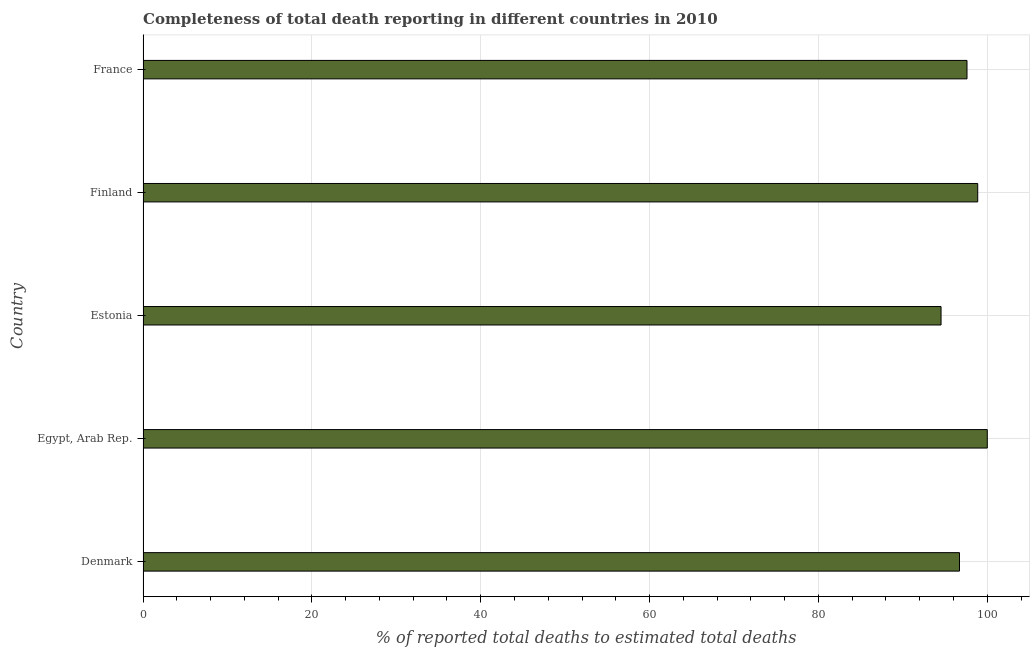Does the graph contain any zero values?
Offer a very short reply. No. Does the graph contain grids?
Give a very brief answer. Yes. What is the title of the graph?
Offer a very short reply. Completeness of total death reporting in different countries in 2010. What is the label or title of the X-axis?
Give a very brief answer. % of reported total deaths to estimated total deaths. What is the label or title of the Y-axis?
Your answer should be compact. Country. What is the completeness of total death reports in France?
Offer a very short reply. 97.6. Across all countries, what is the minimum completeness of total death reports?
Keep it short and to the point. 94.52. In which country was the completeness of total death reports maximum?
Provide a short and direct response. Egypt, Arab Rep. In which country was the completeness of total death reports minimum?
Give a very brief answer. Estonia. What is the sum of the completeness of total death reports?
Your answer should be very brief. 487.7. What is the difference between the completeness of total death reports in Egypt, Arab Rep. and Finland?
Offer a terse response. 1.13. What is the average completeness of total death reports per country?
Your answer should be compact. 97.54. What is the median completeness of total death reports?
Make the answer very short. 97.6. What is the difference between the highest and the second highest completeness of total death reports?
Give a very brief answer. 1.13. What is the difference between the highest and the lowest completeness of total death reports?
Keep it short and to the point. 5.48. In how many countries, is the completeness of total death reports greater than the average completeness of total death reports taken over all countries?
Provide a short and direct response. 3. How many bars are there?
Keep it short and to the point. 5. What is the difference between two consecutive major ticks on the X-axis?
Provide a short and direct response. 20. Are the values on the major ticks of X-axis written in scientific E-notation?
Provide a succinct answer. No. What is the % of reported total deaths to estimated total deaths in Denmark?
Your response must be concise. 96.71. What is the % of reported total deaths to estimated total deaths of Estonia?
Your answer should be compact. 94.52. What is the % of reported total deaths to estimated total deaths of Finland?
Offer a very short reply. 98.87. What is the % of reported total deaths to estimated total deaths of France?
Offer a very short reply. 97.6. What is the difference between the % of reported total deaths to estimated total deaths in Denmark and Egypt, Arab Rep.?
Ensure brevity in your answer.  -3.29. What is the difference between the % of reported total deaths to estimated total deaths in Denmark and Estonia?
Your answer should be compact. 2.19. What is the difference between the % of reported total deaths to estimated total deaths in Denmark and Finland?
Offer a very short reply. -2.16. What is the difference between the % of reported total deaths to estimated total deaths in Denmark and France?
Keep it short and to the point. -0.89. What is the difference between the % of reported total deaths to estimated total deaths in Egypt, Arab Rep. and Estonia?
Make the answer very short. 5.48. What is the difference between the % of reported total deaths to estimated total deaths in Egypt, Arab Rep. and Finland?
Provide a short and direct response. 1.13. What is the difference between the % of reported total deaths to estimated total deaths in Egypt, Arab Rep. and France?
Offer a terse response. 2.4. What is the difference between the % of reported total deaths to estimated total deaths in Estonia and Finland?
Keep it short and to the point. -4.35. What is the difference between the % of reported total deaths to estimated total deaths in Estonia and France?
Give a very brief answer. -3.08. What is the difference between the % of reported total deaths to estimated total deaths in Finland and France?
Make the answer very short. 1.27. What is the ratio of the % of reported total deaths to estimated total deaths in Denmark to that in France?
Your answer should be compact. 0.99. What is the ratio of the % of reported total deaths to estimated total deaths in Egypt, Arab Rep. to that in Estonia?
Give a very brief answer. 1.06. What is the ratio of the % of reported total deaths to estimated total deaths in Estonia to that in Finland?
Offer a very short reply. 0.96. What is the ratio of the % of reported total deaths to estimated total deaths in Estonia to that in France?
Your answer should be compact. 0.97. 